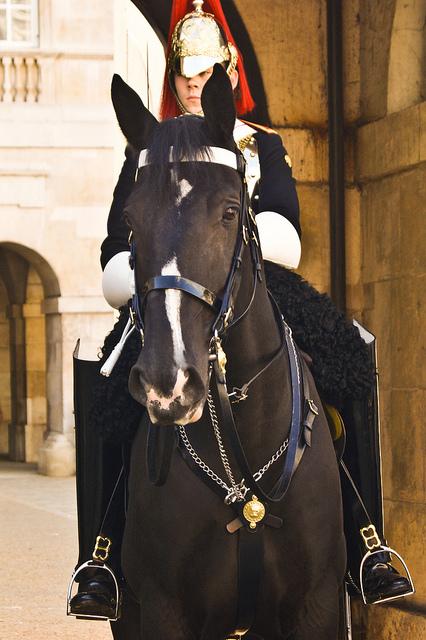Is this man a palace guard?
Short answer required. Yes. What is the position of the person riding the horse?
Short answer required. Sitting. What is the man doing?
Keep it brief. Riding horse. 